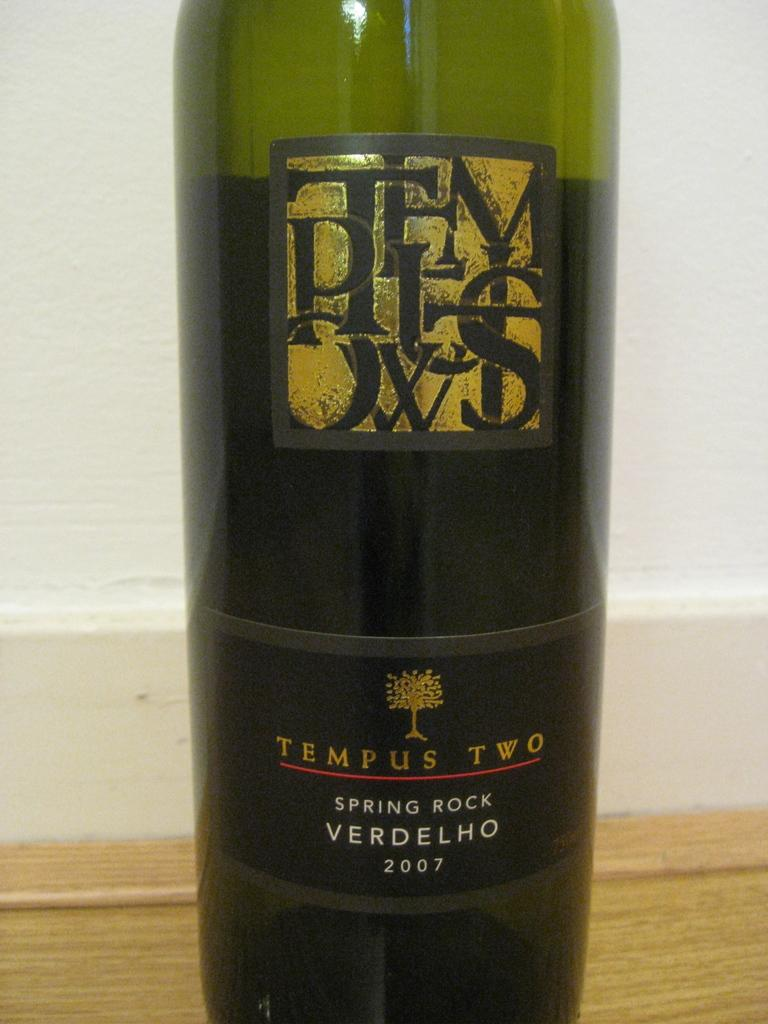<image>
Offer a succinct explanation of the picture presented. A bottle of Tempus Two spring rock 2007 wine. 